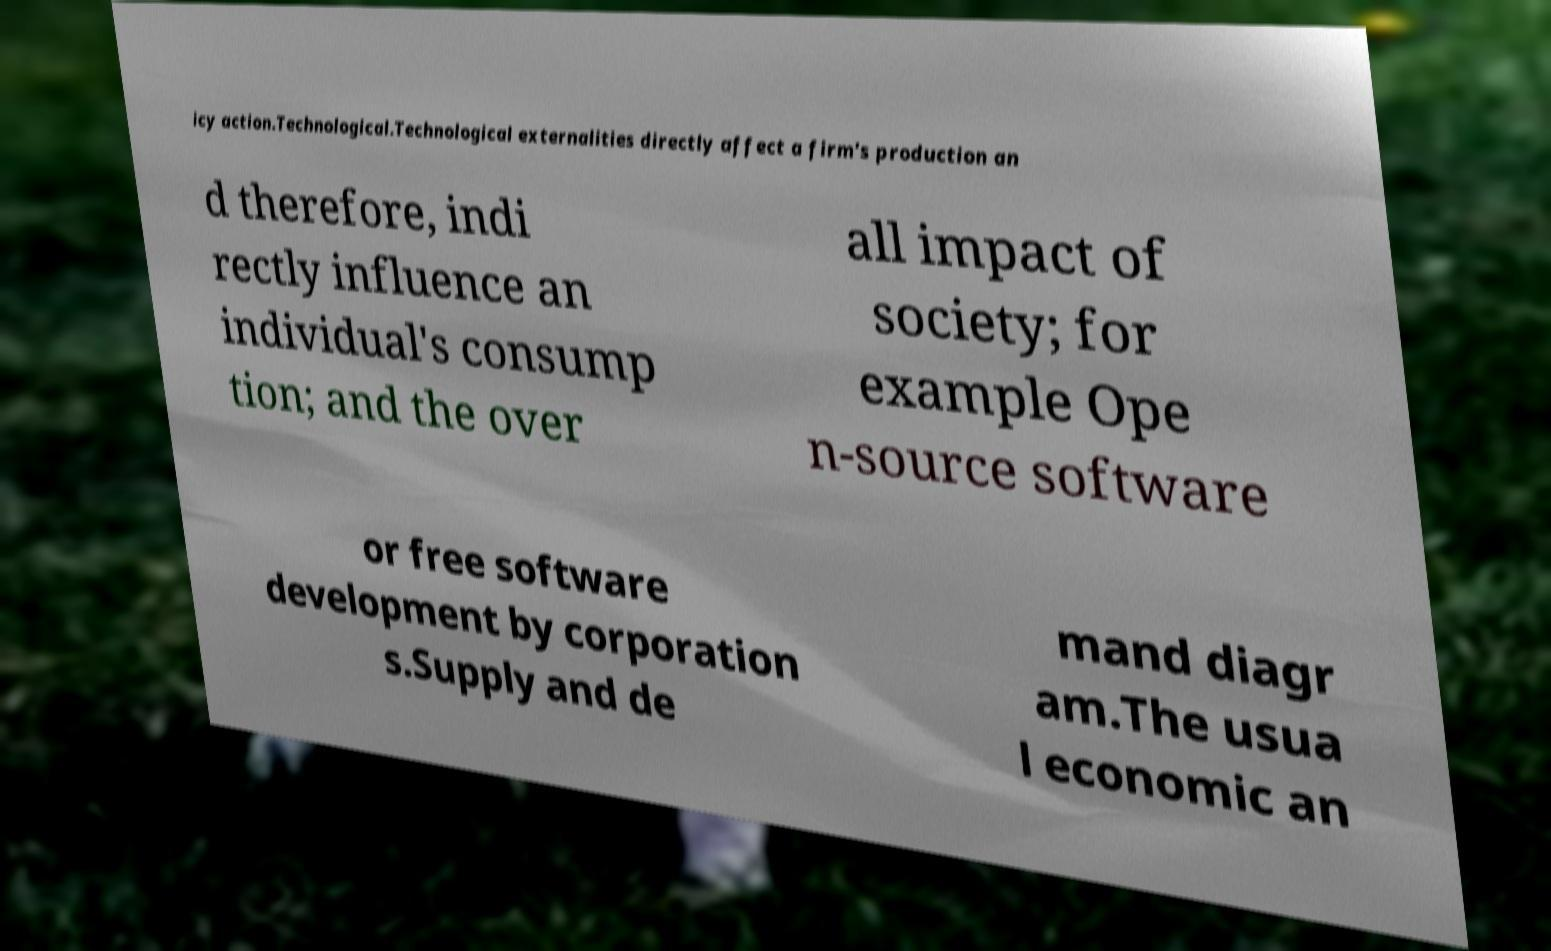Please read and relay the text visible in this image. What does it say? icy action.Technological.Technological externalities directly affect a firm's production an d therefore, indi rectly influence an individual's consump tion; and the over all impact of society; for example Ope n-source software or free software development by corporation s.Supply and de mand diagr am.The usua l economic an 